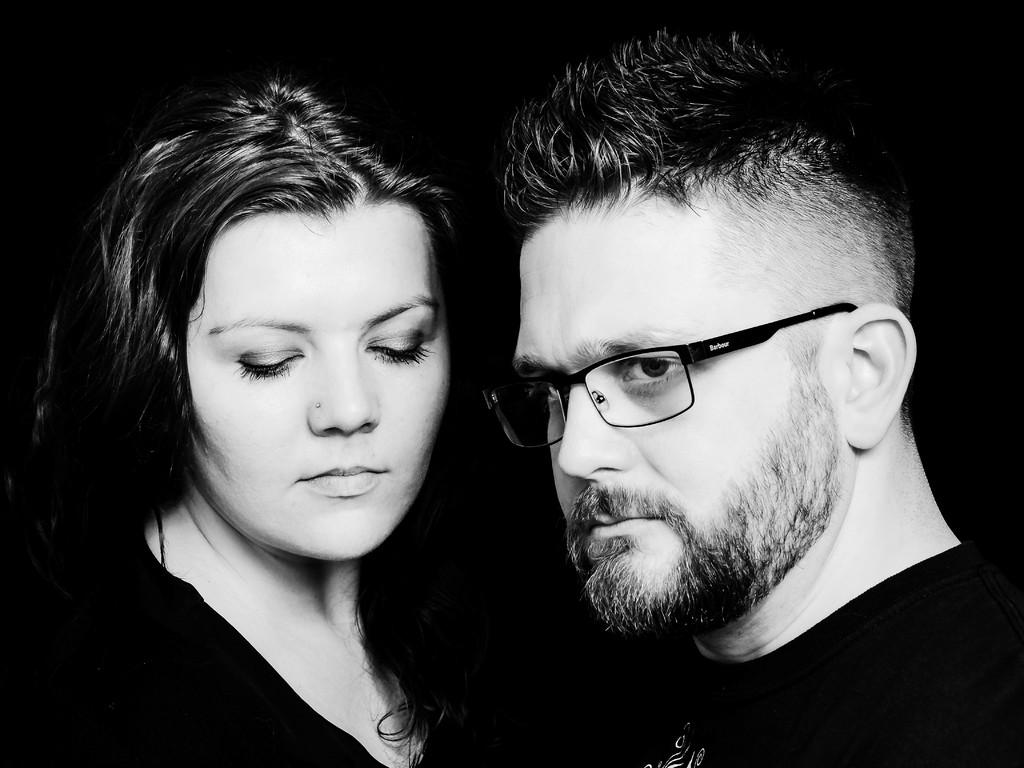How many people are in the image? There are two persons in the image. What color are the dresses of the people in the image? Both persons are wearing black color dress. Can you describe any specific feature of one of the persons? The right side person is wearing spectacles. What is the color of the background in the image? The background of the image is dark. What type of wine is being served at the attraction in the image? There is no wine or attraction present in the image; it features two persons wearing black dresses with a dark background. How many chairs are visible in the image? There are no chairs visible in the image. 